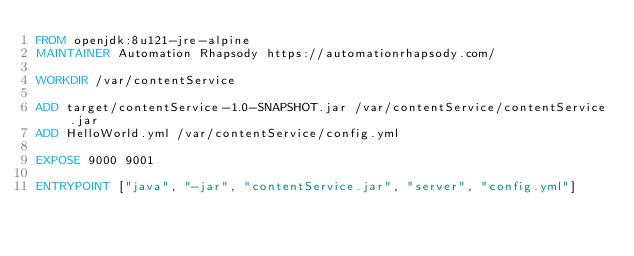Convert code to text. <code><loc_0><loc_0><loc_500><loc_500><_Dockerfile_>FROM openjdk:8u121-jre-alpine
MAINTAINER Automation Rhapsody https://automationrhapsody.com/
 
WORKDIR /var/contentService
 
ADD target/contentService-1.0-SNAPSHOT.jar /var/contentService/contentService.jar
ADD HelloWorld.yml /var/contentService/config.yml
 
EXPOSE 9000 9001
 
ENTRYPOINT ["java", "-jar", "contentService.jar", "server", "config.yml"]</code> 